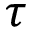<formula> <loc_0><loc_0><loc_500><loc_500>\tau</formula> 